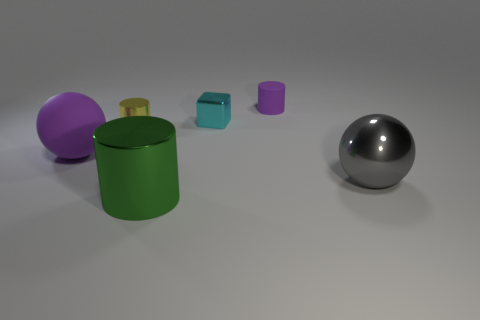Is there any object that stands out in terms of its material or finish? Indeed, the large silver sphere on the right side of the image stands out due to its reflective metallic finish, which contrasts with the matte surfaces of the other colored objects. 